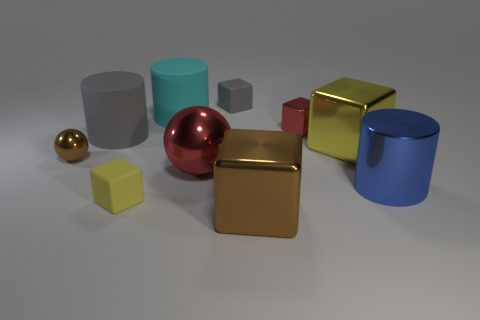What is the material of the big cube that is the same color as the small shiny ball?
Ensure brevity in your answer.  Metal. What number of big purple cubes are there?
Ensure brevity in your answer.  0. Are there fewer gray matte cylinders than objects?
Offer a very short reply. Yes. There is a yellow object that is the same size as the red metallic cube; what material is it?
Your response must be concise. Rubber. How many objects are things or big blue metal objects?
Your answer should be compact. 10. What number of cylinders are both behind the yellow metallic object and in front of the cyan thing?
Give a very brief answer. 1. Is the number of cubes that are right of the big gray matte object less than the number of red metallic things?
Give a very brief answer. No. What shape is the yellow metal thing that is the same size as the cyan matte cylinder?
Offer a very short reply. Cube. What number of other things are there of the same color as the metal cylinder?
Provide a succinct answer. 0. Is the size of the blue object the same as the red metal cube?
Keep it short and to the point. No. 